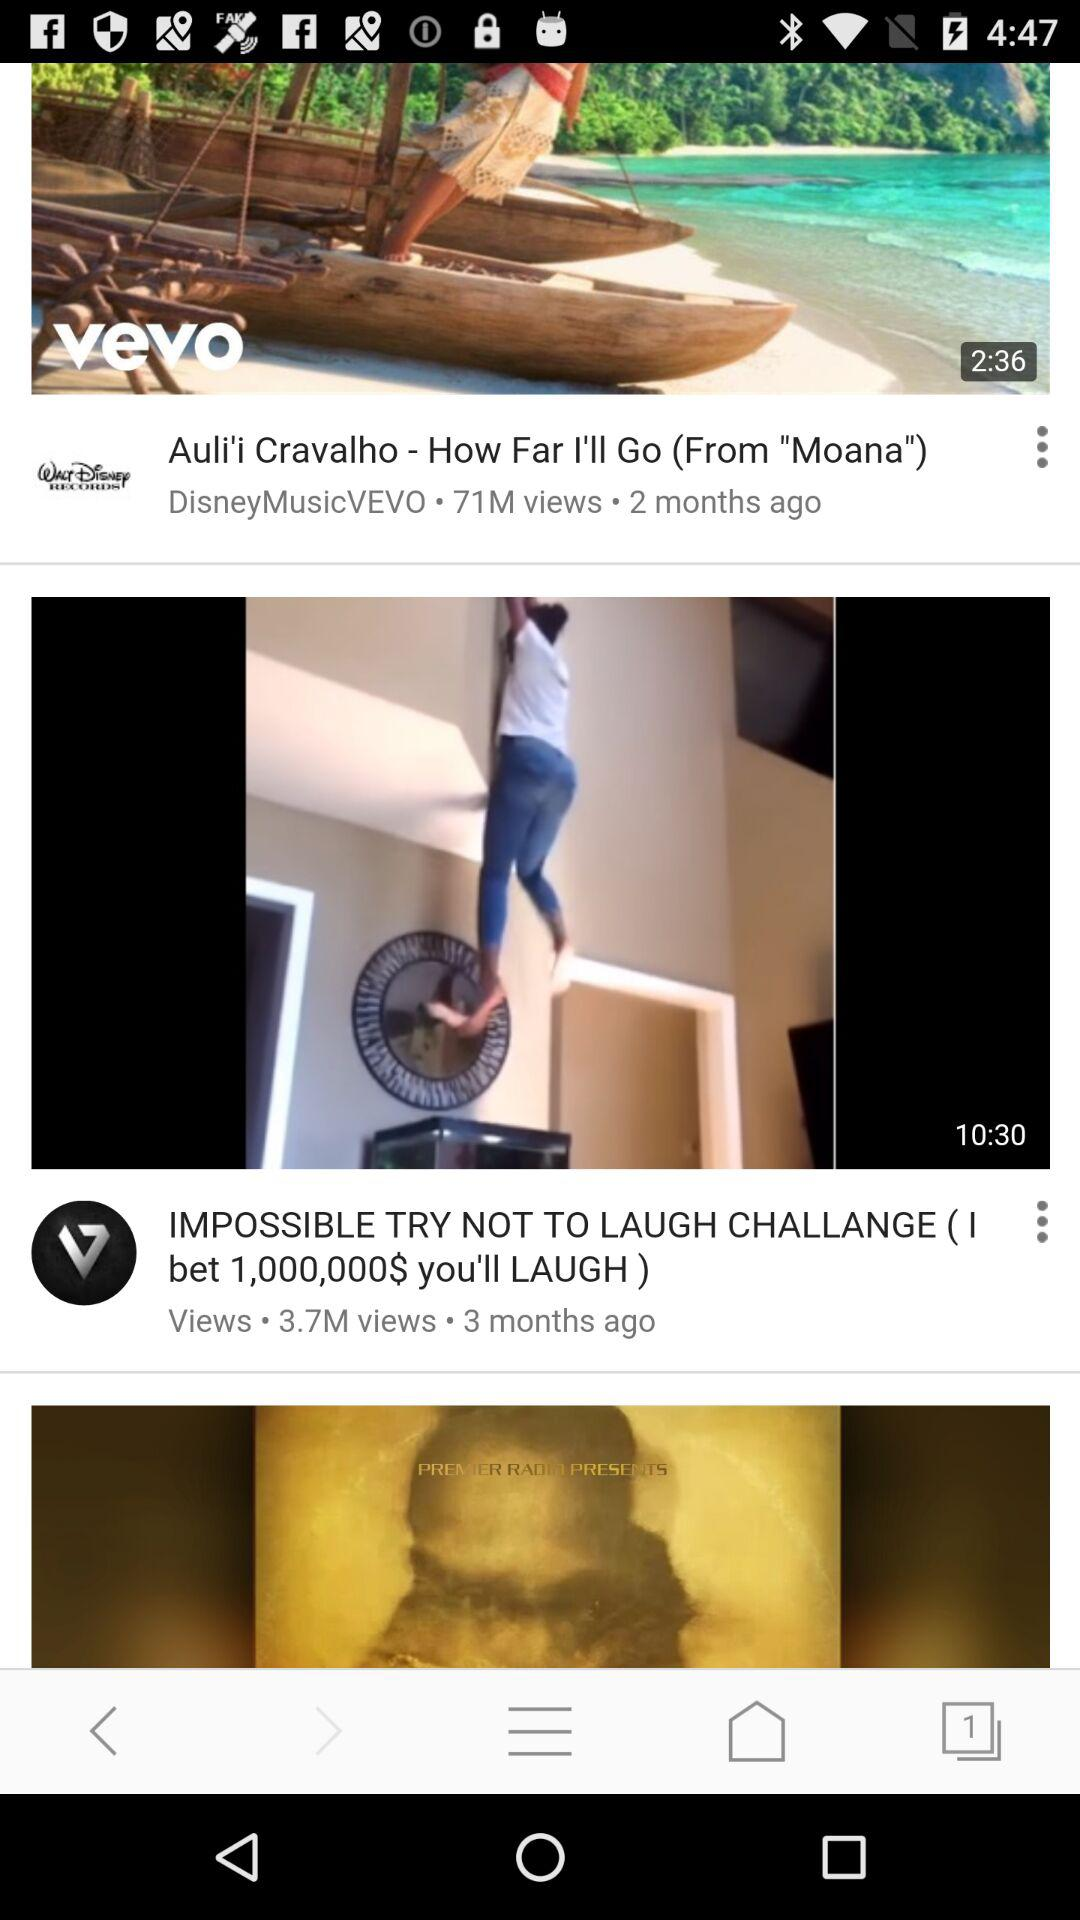What is the duration of the video "Auli'i Cravalho - How Far I'll Go (From "Moana")"? The duration of the video "Auli'i Cravalho - How Far I'll Go (From "Moana")" is 2 minutes and 36 seconds. 